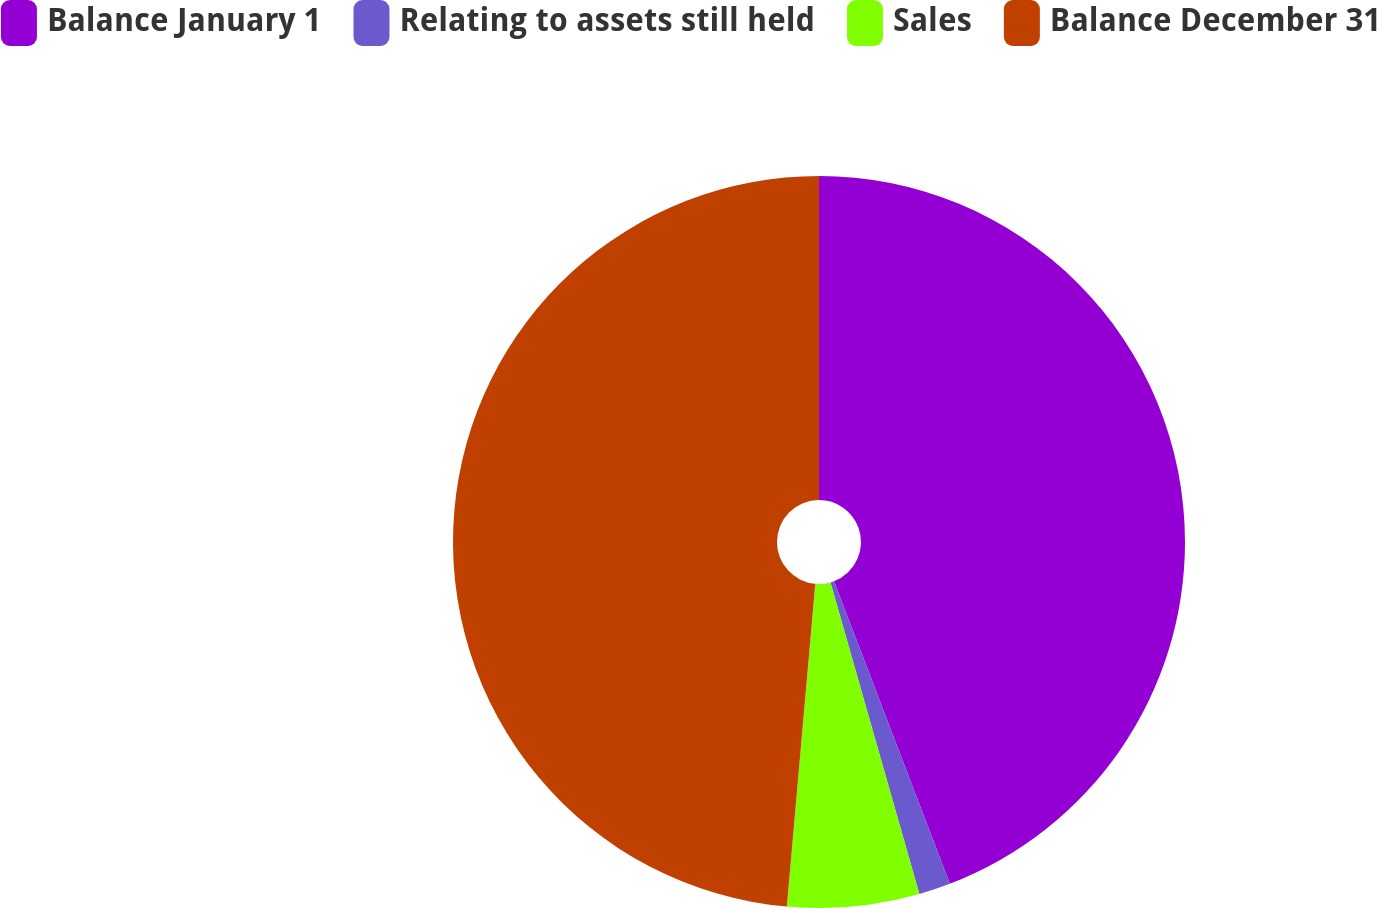<chart> <loc_0><loc_0><loc_500><loc_500><pie_chart><fcel>Balance January 1<fcel>Relating to assets still held<fcel>Sales<fcel>Balance December 31<nl><fcel>44.18%<fcel>1.4%<fcel>5.82%<fcel>48.6%<nl></chart> 